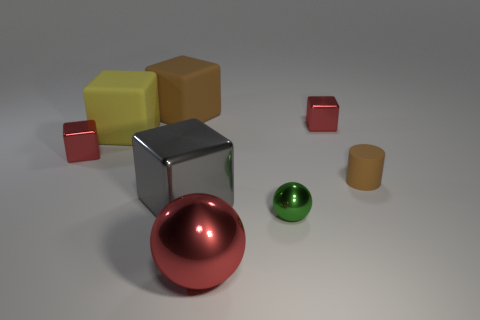Does the brown object on the left side of the tiny brown matte object have the same material as the cube that is in front of the small matte thing?
Provide a succinct answer. No. What size is the green ball?
Offer a very short reply. Small. There is a green object that is the same shape as the big red shiny thing; what is its size?
Provide a short and direct response. Small. What number of metal cubes are right of the big brown rubber thing?
Provide a succinct answer. 2. There is a big block in front of the brown rubber thing that is in front of the brown rubber block; what is its color?
Offer a terse response. Gray. Is there anything else that has the same shape as the small brown rubber thing?
Give a very brief answer. No. Are there the same number of tiny metal cubes to the left of the small cylinder and cubes that are on the left side of the large brown cube?
Offer a terse response. Yes. How many spheres are large objects or brown objects?
Provide a succinct answer. 1. How many other things are made of the same material as the big brown cube?
Give a very brief answer. 2. The red object that is to the right of the small green sphere has what shape?
Your answer should be compact. Cube. 